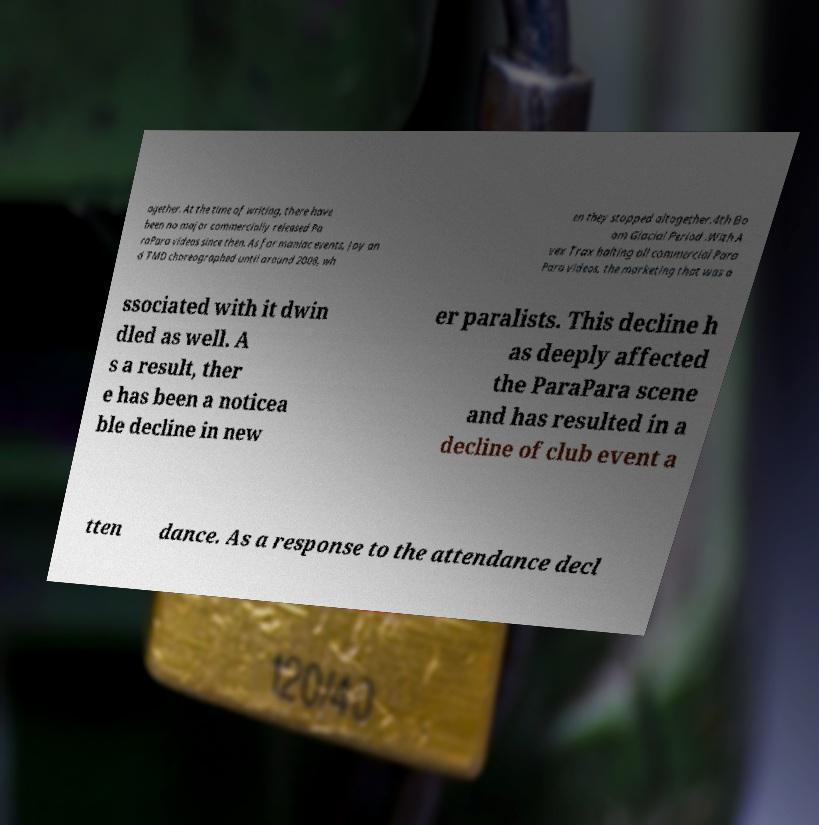Can you read and provide the text displayed in the image?This photo seems to have some interesting text. Can you extract and type it out for me? ogether. At the time of writing, there have been no major commercially released Pa raPara videos since then. As for maniac events, Joy an d TMD choreographed until around 2008, wh en they stopped altogether.4th Bo om Glacial Period .With A vex Trax halting all commercial Para Para videos, the marketing that was a ssociated with it dwin dled as well. A s a result, ther e has been a noticea ble decline in new er paralists. This decline h as deeply affected the ParaPara scene and has resulted in a decline of club event a tten dance. As a response to the attendance decl 